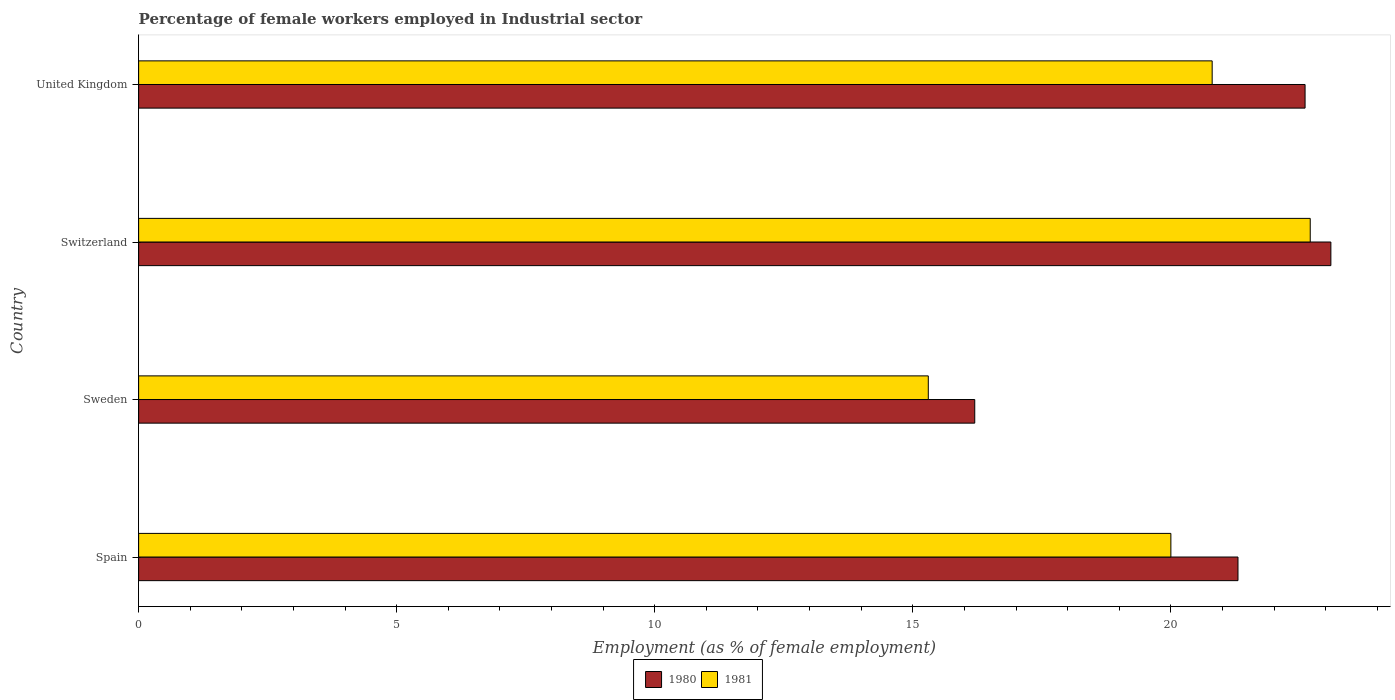Are the number of bars per tick equal to the number of legend labels?
Offer a very short reply. Yes. Are the number of bars on each tick of the Y-axis equal?
Your answer should be very brief. Yes. How many bars are there on the 2nd tick from the bottom?
Your answer should be very brief. 2. What is the label of the 2nd group of bars from the top?
Provide a succinct answer. Switzerland. In how many cases, is the number of bars for a given country not equal to the number of legend labels?
Your answer should be very brief. 0. What is the percentage of females employed in Industrial sector in 1980 in Switzerland?
Provide a succinct answer. 23.1. Across all countries, what is the maximum percentage of females employed in Industrial sector in 1980?
Provide a short and direct response. 23.1. Across all countries, what is the minimum percentage of females employed in Industrial sector in 1981?
Give a very brief answer. 15.3. In which country was the percentage of females employed in Industrial sector in 1980 maximum?
Offer a very short reply. Switzerland. In which country was the percentage of females employed in Industrial sector in 1981 minimum?
Provide a succinct answer. Sweden. What is the total percentage of females employed in Industrial sector in 1981 in the graph?
Your answer should be very brief. 78.8. What is the difference between the percentage of females employed in Industrial sector in 1980 in Sweden and that in United Kingdom?
Provide a short and direct response. -6.4. What is the difference between the percentage of females employed in Industrial sector in 1981 in Switzerland and the percentage of females employed in Industrial sector in 1980 in United Kingdom?
Make the answer very short. 0.1. What is the average percentage of females employed in Industrial sector in 1981 per country?
Keep it short and to the point. 19.7. What is the difference between the percentage of females employed in Industrial sector in 1981 and percentage of females employed in Industrial sector in 1980 in Spain?
Offer a terse response. -1.3. In how many countries, is the percentage of females employed in Industrial sector in 1980 greater than 22 %?
Ensure brevity in your answer.  2. What is the ratio of the percentage of females employed in Industrial sector in 1981 in Switzerland to that in United Kingdom?
Offer a terse response. 1.09. What is the difference between the highest and the lowest percentage of females employed in Industrial sector in 1981?
Provide a succinct answer. 7.4. In how many countries, is the percentage of females employed in Industrial sector in 1980 greater than the average percentage of females employed in Industrial sector in 1980 taken over all countries?
Ensure brevity in your answer.  3. Is the sum of the percentage of females employed in Industrial sector in 1981 in Sweden and United Kingdom greater than the maximum percentage of females employed in Industrial sector in 1980 across all countries?
Your response must be concise. Yes. What does the 1st bar from the top in United Kingdom represents?
Provide a succinct answer. 1981. How many bars are there?
Make the answer very short. 8. What is the difference between two consecutive major ticks on the X-axis?
Provide a succinct answer. 5. Where does the legend appear in the graph?
Keep it short and to the point. Bottom center. What is the title of the graph?
Provide a short and direct response. Percentage of female workers employed in Industrial sector. What is the label or title of the X-axis?
Provide a succinct answer. Employment (as % of female employment). What is the label or title of the Y-axis?
Ensure brevity in your answer.  Country. What is the Employment (as % of female employment) of 1980 in Spain?
Keep it short and to the point. 21.3. What is the Employment (as % of female employment) in 1980 in Sweden?
Offer a terse response. 16.2. What is the Employment (as % of female employment) of 1981 in Sweden?
Provide a succinct answer. 15.3. What is the Employment (as % of female employment) of 1980 in Switzerland?
Offer a terse response. 23.1. What is the Employment (as % of female employment) in 1981 in Switzerland?
Make the answer very short. 22.7. What is the Employment (as % of female employment) of 1980 in United Kingdom?
Give a very brief answer. 22.6. What is the Employment (as % of female employment) of 1981 in United Kingdom?
Your answer should be very brief. 20.8. Across all countries, what is the maximum Employment (as % of female employment) in 1980?
Give a very brief answer. 23.1. Across all countries, what is the maximum Employment (as % of female employment) in 1981?
Your response must be concise. 22.7. Across all countries, what is the minimum Employment (as % of female employment) of 1980?
Offer a terse response. 16.2. Across all countries, what is the minimum Employment (as % of female employment) in 1981?
Keep it short and to the point. 15.3. What is the total Employment (as % of female employment) in 1980 in the graph?
Your answer should be very brief. 83.2. What is the total Employment (as % of female employment) in 1981 in the graph?
Provide a succinct answer. 78.8. What is the difference between the Employment (as % of female employment) of 1980 in Spain and that in Sweden?
Provide a succinct answer. 5.1. What is the difference between the Employment (as % of female employment) of 1981 in Spain and that in Sweden?
Make the answer very short. 4.7. What is the difference between the Employment (as % of female employment) in 1980 in Spain and that in Switzerland?
Your answer should be very brief. -1.8. What is the difference between the Employment (as % of female employment) in 1981 in Spain and that in Switzerland?
Keep it short and to the point. -2.7. What is the difference between the Employment (as % of female employment) of 1980 in Sweden and that in Switzerland?
Offer a terse response. -6.9. What is the difference between the Employment (as % of female employment) in 1980 in Switzerland and that in United Kingdom?
Provide a short and direct response. 0.5. What is the difference between the Employment (as % of female employment) of 1981 in Switzerland and that in United Kingdom?
Offer a terse response. 1.9. What is the difference between the Employment (as % of female employment) in 1980 in Spain and the Employment (as % of female employment) in 1981 in Switzerland?
Your answer should be compact. -1.4. What is the difference between the Employment (as % of female employment) in 1980 in Spain and the Employment (as % of female employment) in 1981 in United Kingdom?
Your answer should be compact. 0.5. What is the difference between the Employment (as % of female employment) in 1980 in Sweden and the Employment (as % of female employment) in 1981 in Switzerland?
Give a very brief answer. -6.5. What is the difference between the Employment (as % of female employment) of 1980 in Sweden and the Employment (as % of female employment) of 1981 in United Kingdom?
Keep it short and to the point. -4.6. What is the average Employment (as % of female employment) of 1980 per country?
Offer a very short reply. 20.8. What is the difference between the Employment (as % of female employment) in 1980 and Employment (as % of female employment) in 1981 in Spain?
Provide a succinct answer. 1.3. What is the difference between the Employment (as % of female employment) of 1980 and Employment (as % of female employment) of 1981 in Sweden?
Offer a very short reply. 0.9. What is the ratio of the Employment (as % of female employment) of 1980 in Spain to that in Sweden?
Ensure brevity in your answer.  1.31. What is the ratio of the Employment (as % of female employment) in 1981 in Spain to that in Sweden?
Your answer should be very brief. 1.31. What is the ratio of the Employment (as % of female employment) of 1980 in Spain to that in Switzerland?
Offer a terse response. 0.92. What is the ratio of the Employment (as % of female employment) in 1981 in Spain to that in Switzerland?
Your answer should be compact. 0.88. What is the ratio of the Employment (as % of female employment) in 1980 in Spain to that in United Kingdom?
Provide a short and direct response. 0.94. What is the ratio of the Employment (as % of female employment) of 1981 in Spain to that in United Kingdom?
Keep it short and to the point. 0.96. What is the ratio of the Employment (as % of female employment) of 1980 in Sweden to that in Switzerland?
Your answer should be compact. 0.7. What is the ratio of the Employment (as % of female employment) of 1981 in Sweden to that in Switzerland?
Your response must be concise. 0.67. What is the ratio of the Employment (as % of female employment) of 1980 in Sweden to that in United Kingdom?
Provide a succinct answer. 0.72. What is the ratio of the Employment (as % of female employment) of 1981 in Sweden to that in United Kingdom?
Your answer should be compact. 0.74. What is the ratio of the Employment (as % of female employment) in 1980 in Switzerland to that in United Kingdom?
Your response must be concise. 1.02. What is the ratio of the Employment (as % of female employment) of 1981 in Switzerland to that in United Kingdom?
Make the answer very short. 1.09. What is the difference between the highest and the second highest Employment (as % of female employment) of 1981?
Make the answer very short. 1.9. What is the difference between the highest and the lowest Employment (as % of female employment) of 1980?
Give a very brief answer. 6.9. 